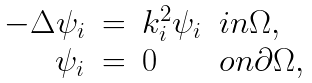<formula> <loc_0><loc_0><loc_500><loc_500>\begin{array} { r c l l } - \Delta \psi _ { i } & = & k _ { i } ^ { 2 } \psi _ { i } & i n \Omega , \\ \psi _ { i } & = & 0 & o n \partial \Omega , \end{array}</formula> 